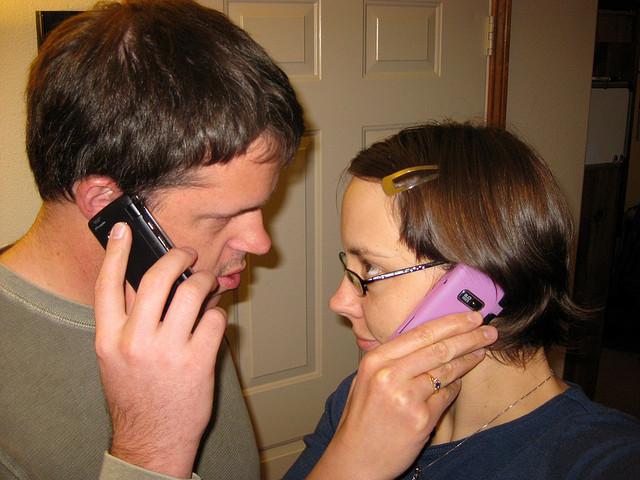What the picture taken in a house?
Answer briefly. Yes. What color is the woman's phone?
Concise answer only. Purple. What are these people holding?
Be succinct. Cell phones. 